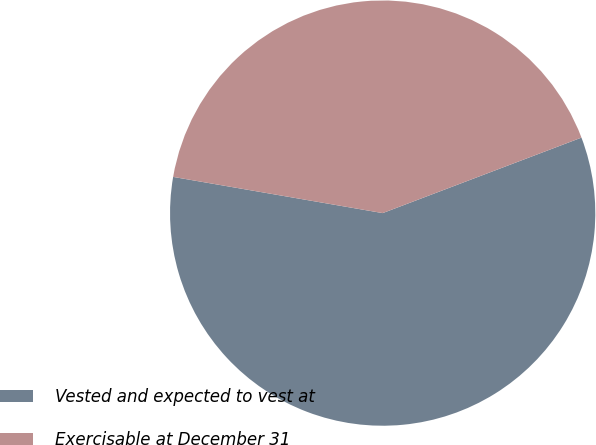Convert chart to OTSL. <chart><loc_0><loc_0><loc_500><loc_500><pie_chart><fcel>Vested and expected to vest at<fcel>Exercisable at December 31<nl><fcel>58.5%<fcel>41.5%<nl></chart> 